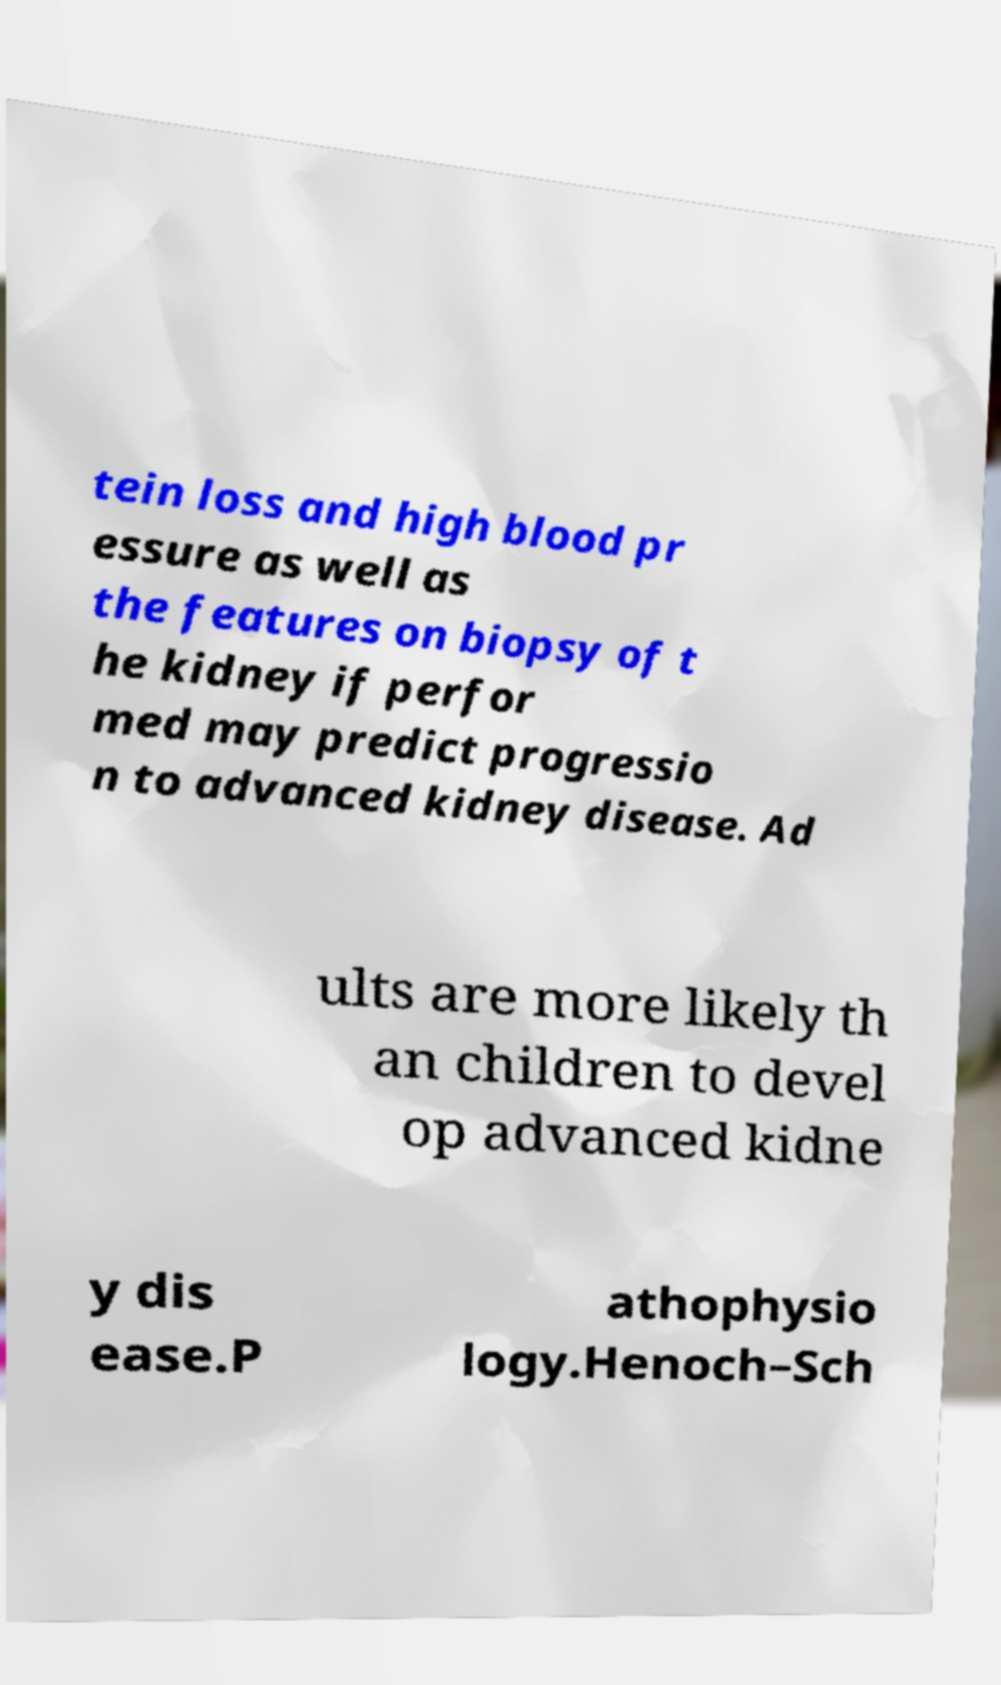Can you accurately transcribe the text from the provided image for me? tein loss and high blood pr essure as well as the features on biopsy of t he kidney if perfor med may predict progressio n to advanced kidney disease. Ad ults are more likely th an children to devel op advanced kidne y dis ease.P athophysio logy.Henoch–Sch 